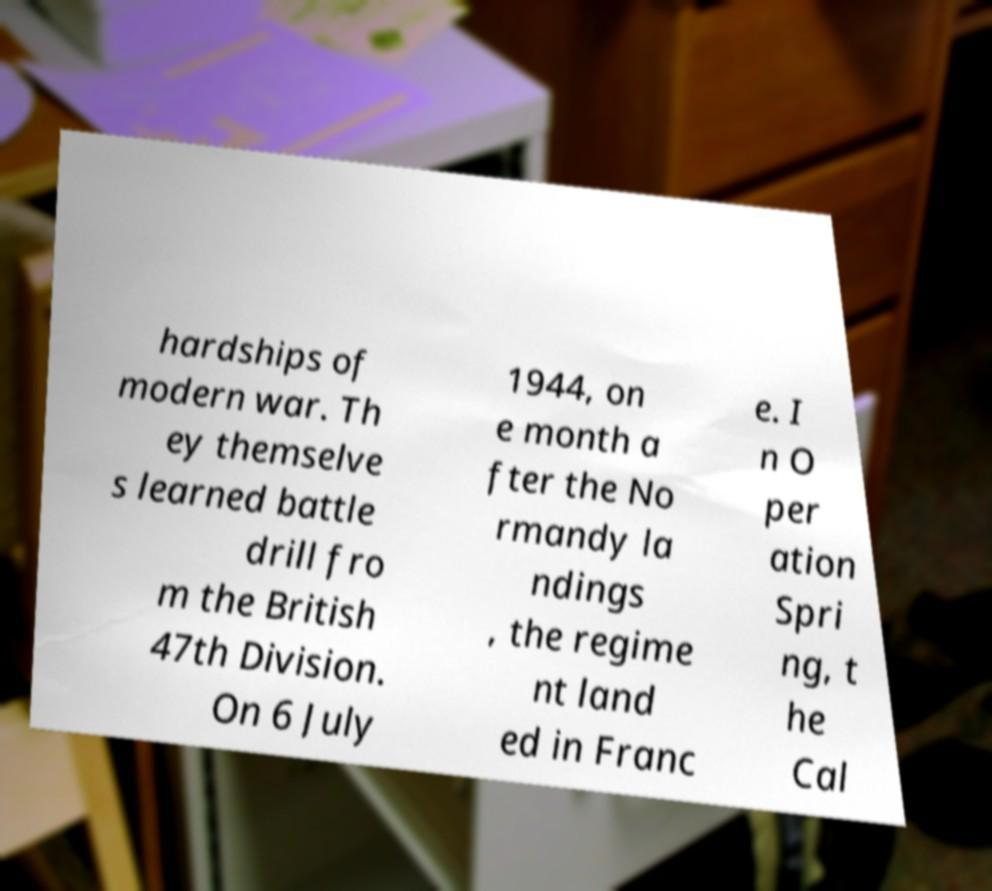There's text embedded in this image that I need extracted. Can you transcribe it verbatim? hardships of modern war. Th ey themselve s learned battle drill fro m the British 47th Division. On 6 July 1944, on e month a fter the No rmandy la ndings , the regime nt land ed in Franc e. I n O per ation Spri ng, t he Cal 